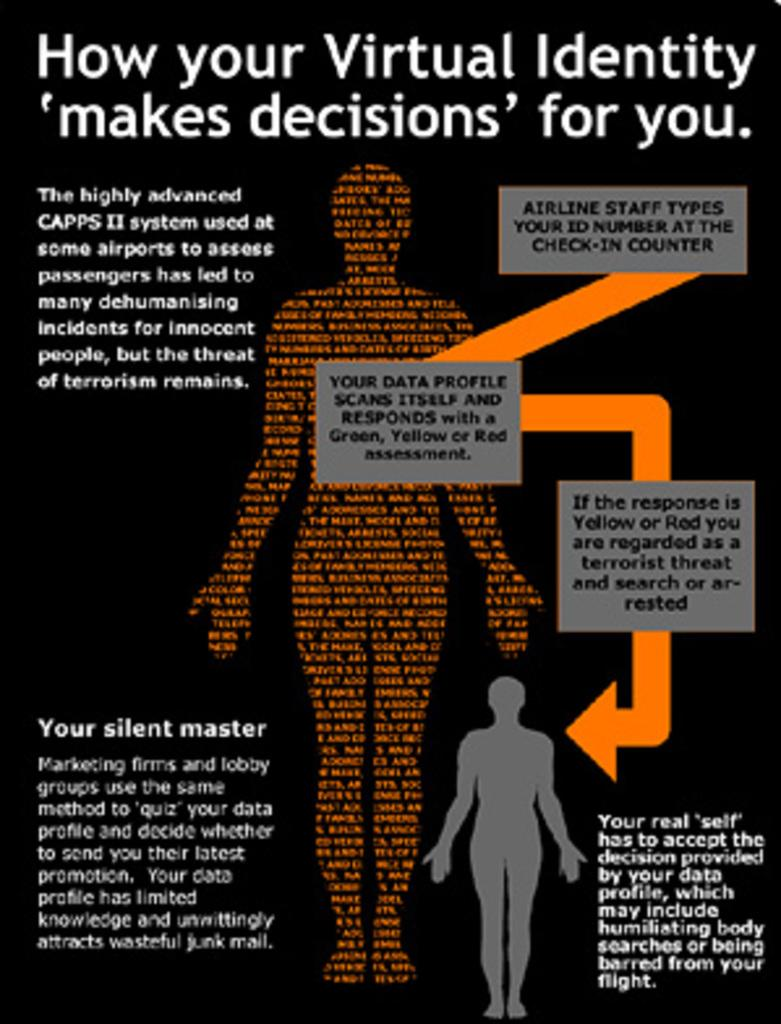What is present on the poster in the image? There is a poster in the image, and there is text on the poster. What type of objects are depicted as models in the image? There are models of a human body in the image. Where is the nearest market to the location of the image? The provided facts do not mention a market or its location, so it cannot be determined from the image. What type of room is the image taken in? The provided facts do not specify the type of room or its characteristics, so it cannot be determined from the image. 